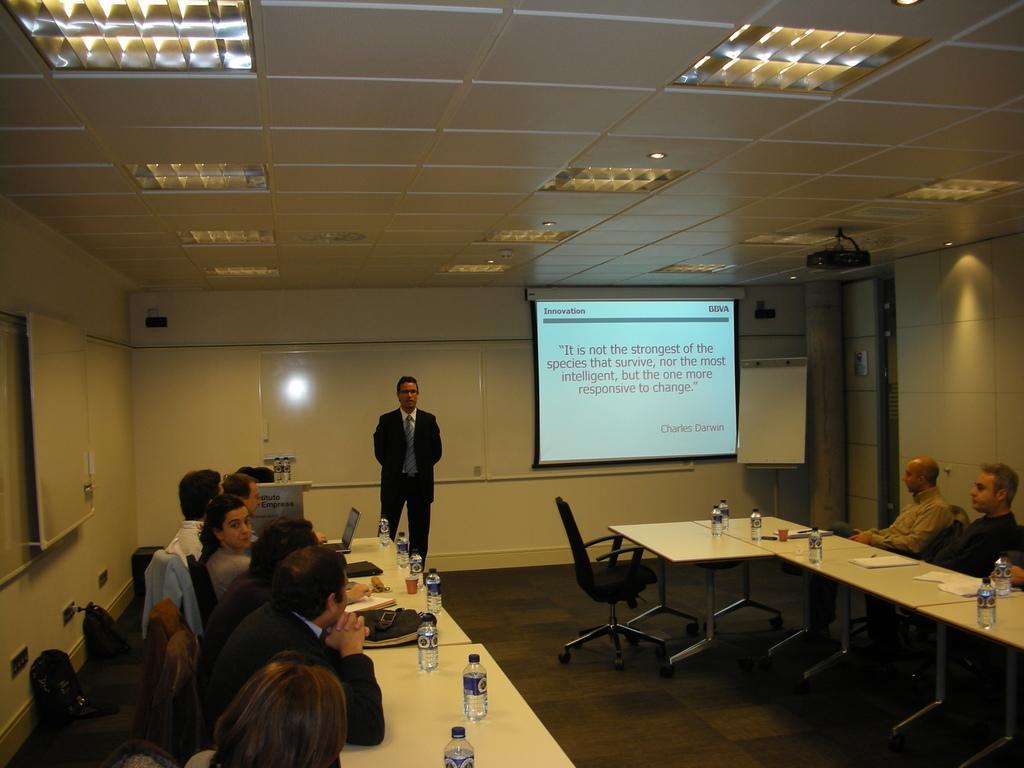Could you give a brief overview of what you see in this image? On the left and right there are few people sitting on the chair at the table. There are bottles,laptops,bags,books and papers on the table. In the background there is a man standing and a screen and wall. On the rooftop there are lights and projector. 